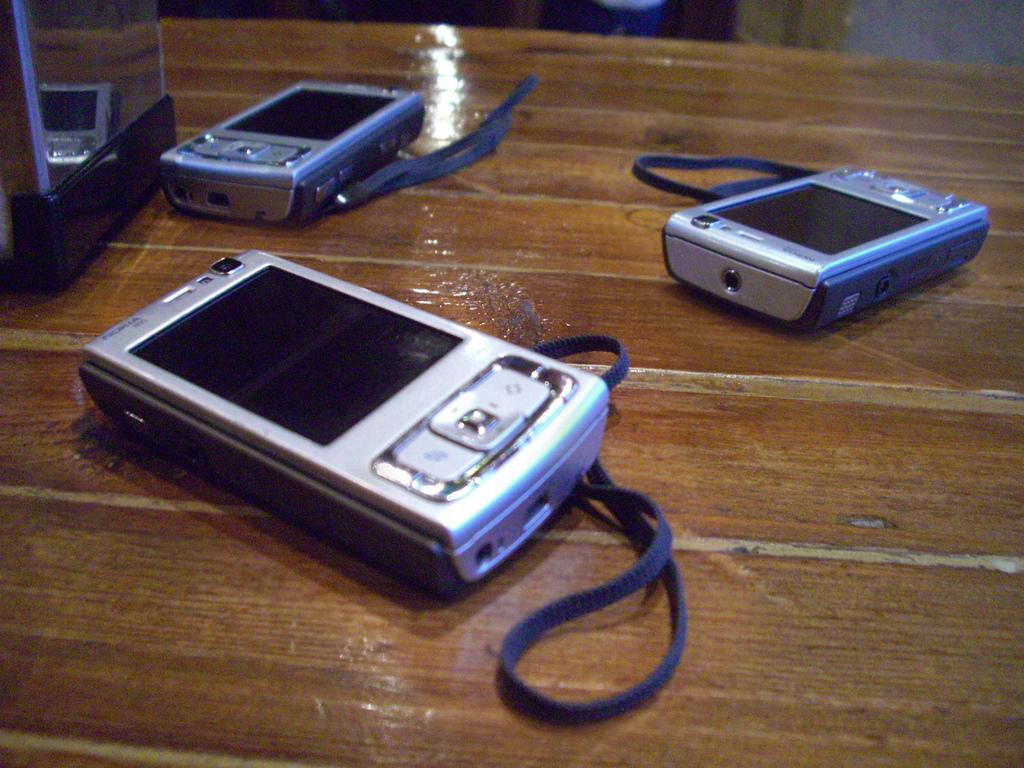What objects are present in the image? There are cameras in the image. Where are the cameras located? The cameras are on a table. What type of rose is depicted in the image? There is no rose present in the image; it features cameras on a table. What fact is being discussed in the image? The image does not depict a discussion or any facts; it simply shows cameras on a table. 